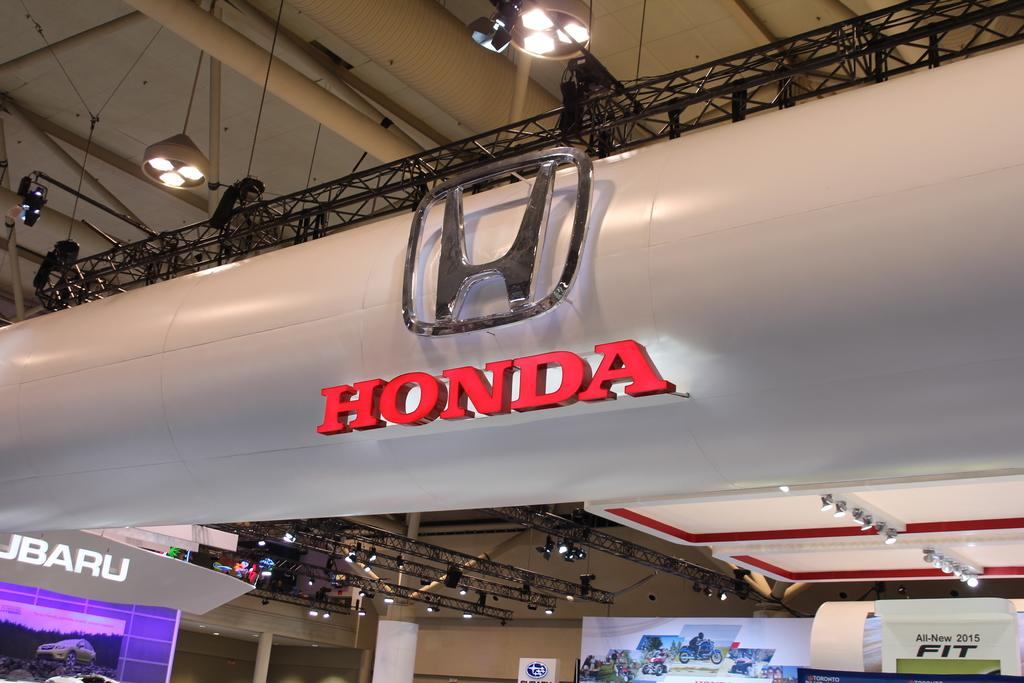<image>
Give a short and clear explanation of the subsequent image. a sign on top of a tank that says 'honda' in red 